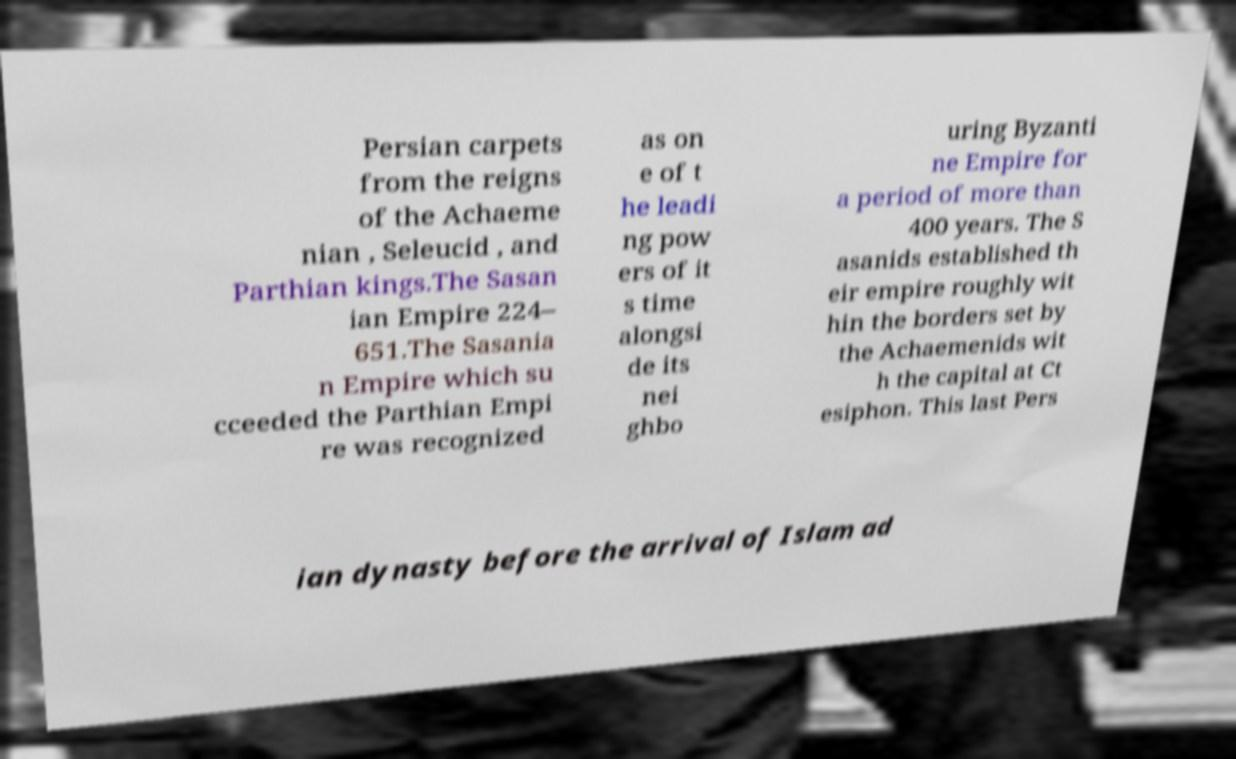Could you extract and type out the text from this image? Persian carpets from the reigns of the Achaeme nian , Seleucid , and Parthian kings.The Sasan ian Empire 224– 651.The Sasania n Empire which su cceeded the Parthian Empi re was recognized as on e of t he leadi ng pow ers of it s time alongsi de its nei ghbo uring Byzanti ne Empire for a period of more than 400 years. The S asanids established th eir empire roughly wit hin the borders set by the Achaemenids wit h the capital at Ct esiphon. This last Pers ian dynasty before the arrival of Islam ad 